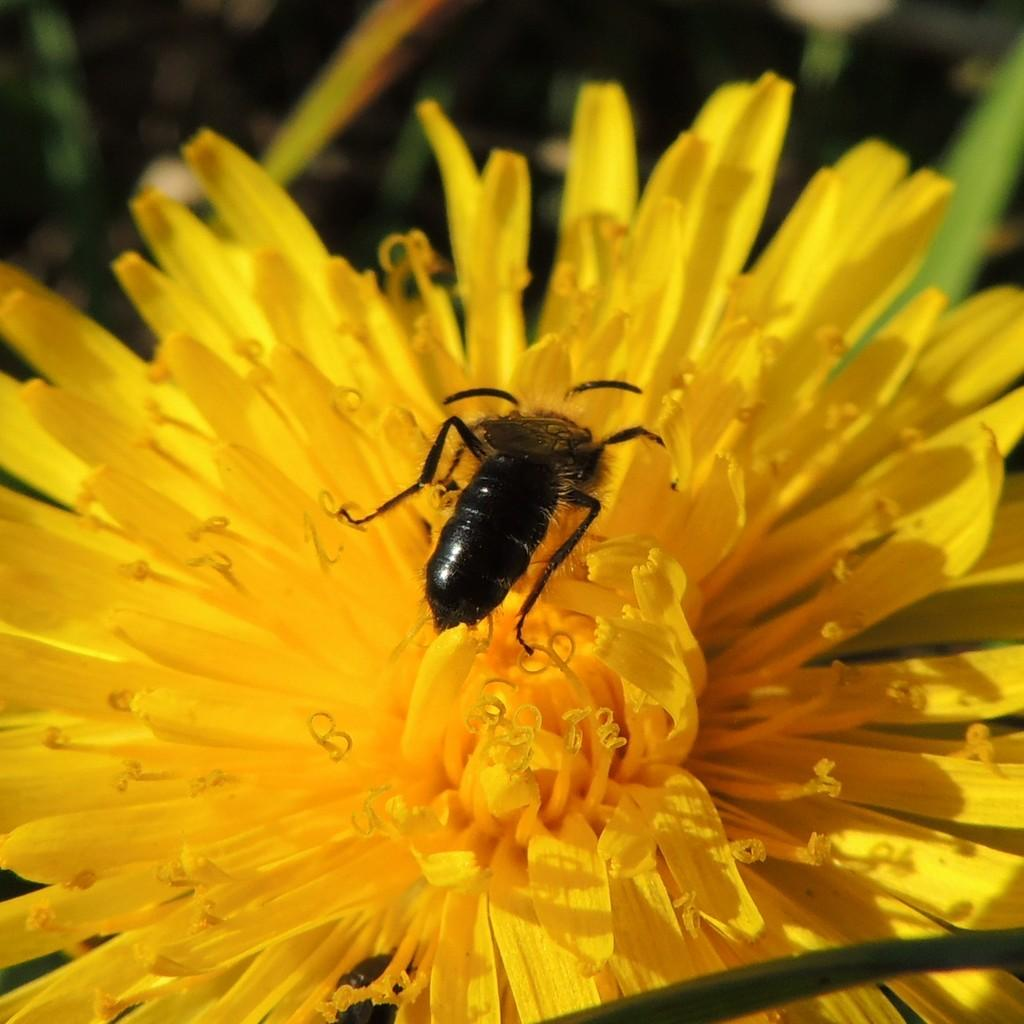What is the main subject of the image? There is a flower in the image. Is there anything else present on the flower? Yes, there is an insect on the flower. What type of drain is visible in the image? There is no drain present in the image; it features a flower with an insect on it. What type of yam is being held by the queen in the image? There is no queen or yam present in the image. 